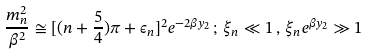<formula> <loc_0><loc_0><loc_500><loc_500>\frac { m _ { n } ^ { 2 } } { \beta ^ { 2 } } \cong [ ( n + \frac { 5 } { 4 } ) \pi + \epsilon _ { n } ] ^ { 2 } e ^ { - 2 \beta y _ { 2 } } \, ; \, \xi _ { n } \ll 1 \, , \, \xi _ { n } e ^ { \beta y _ { 2 } } \gg 1</formula> 